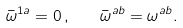Convert formula to latex. <formula><loc_0><loc_0><loc_500><loc_500>\bar { \omega } ^ { 1 a } = 0 \, , \quad \bar { \omega } ^ { a b } = \omega ^ { a b } .</formula> 